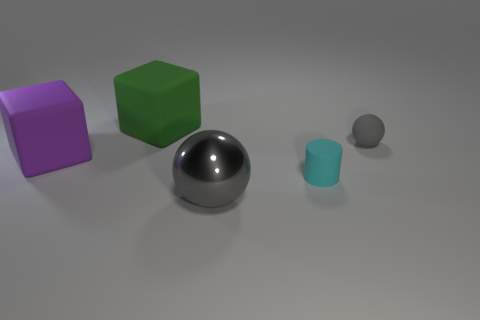What colors are the large blocks in the image? The large blocks in the image are colored purple and green. 